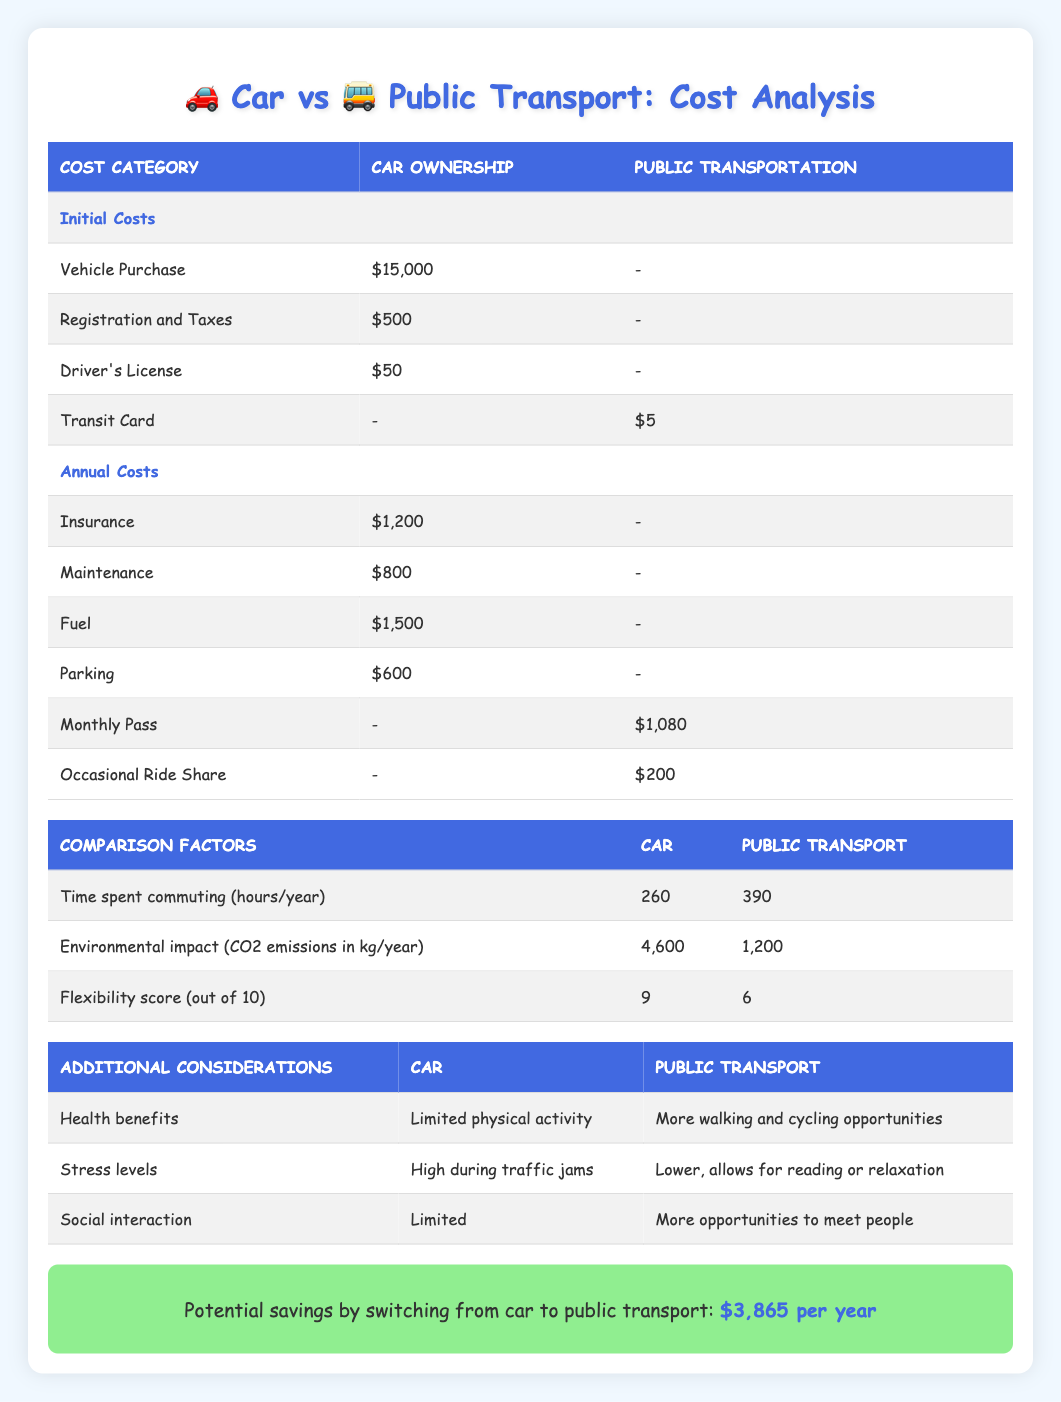What are the initial costs of car ownership? The initial costs for car ownership include the vehicle purchase price of $15,000, registration and taxes of $500, and a driver's license fee of $50. Summing these gives us a total of $15,000 + $500 + $50 = $15,550.
Answer: $15,550 What is the total annual cost of public transportation? The annual costs for public transportation are comprised of a monthly pass totaling $1,080 and occasional ride shares amounting to $200. Therefore, the total annual cost is $1,080 + $200 = $1,280.
Answer: $1,280 Is the environmental impact of car ownership greater than public transportation? To compare, car ownership has an environmental impact of 4,600 kg of CO2 emissions per year, while public transportation has an impact of 1,200 kg. Since 4,600 is greater than 1,200, the statement is true.
Answer: Yes What is the flexibility score difference between car ownership and public transportation? The flexibility score for car ownership is 9, while for public transportation it is 6. Calculating the difference, we find 9 - 6 = 3.
Answer: 3 How much can one potentially save by switching from car ownership to public transportation? The potential savings by switching from car ownership to public transportation is explicitly stated as $3,865, which means this is the exact amount one would save.
Answer: $3,865 Which transportation option has lower stress levels? The stress levels for car ownership are described as "High during traffic jams," while public transportation is described as "Lower, allows for reading or relaxation." Thus, public transportation has lower stress levels.
Answer: Public transportation How does the time spent commuting compare between car ownership and public transportation? The table shows that time spent commuting by car is 260 hours, while public transportation takes 390 hours. To find the difference: 390 - 260 = 130 hours more for public transportation.
Answer: 130 hours more for public transportation What is the total initial cost of public transportation? The only initial cost for public transportation is the transit card priced at $5. Since there are no other initial costs listed, the total remains $5.
Answer: $5 Which transportation option allows for more social interaction? Car ownership is described as having "Limited" social interaction opportunities, while public transportation has "More opportunities to meet people." Hence, public transportation allows for more social interaction.
Answer: Public transportation 